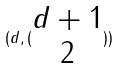Convert formula to latex. <formula><loc_0><loc_0><loc_500><loc_500>( d , ( \begin{matrix} d + 1 \\ 2 \end{matrix} ) )</formula> 